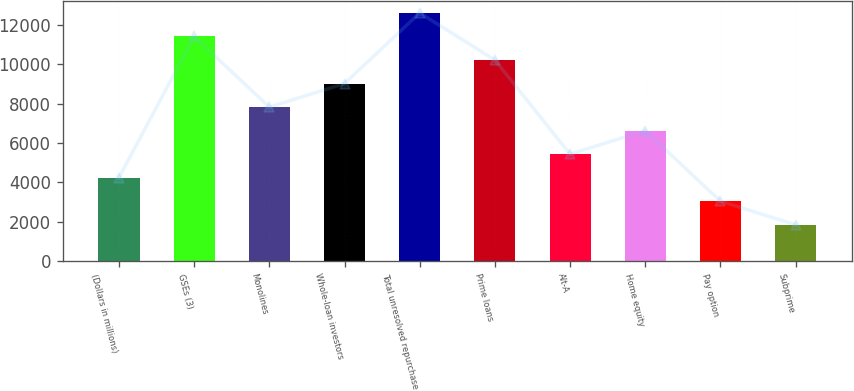Convert chart. <chart><loc_0><loc_0><loc_500><loc_500><bar_chart><fcel>(Dollars in millions)<fcel>GSEs (3)<fcel>Monolines<fcel>Whole-loan investors<fcel>Total unresolved repurchase<fcel>Prime loans<fcel>Alt-A<fcel>Home equity<fcel>Pay option<fcel>Subprime<nl><fcel>4230.1<fcel>11410.3<fcel>7820.2<fcel>9016.9<fcel>12607<fcel>10213.6<fcel>5426.8<fcel>6623.5<fcel>3033.4<fcel>1836.7<nl></chart> 